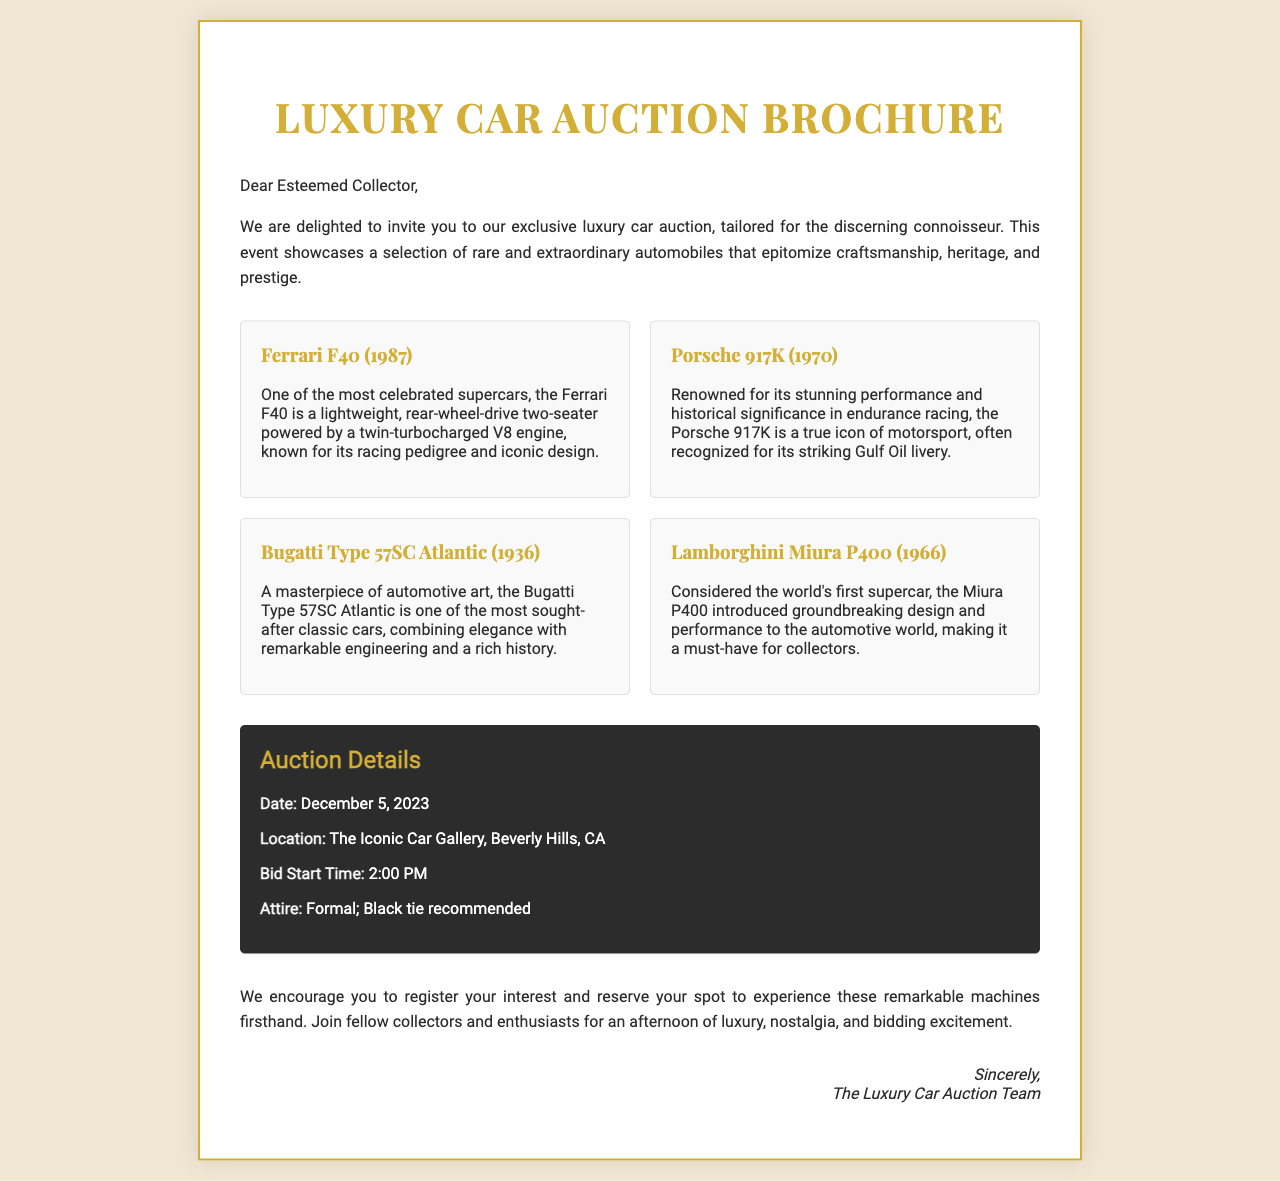What is the date of the auction? The date of the auction is explicitly stated in the document under the auction details section.
Answer: December 5, 2023 Where is the auction taking place? The location of the auction is provided in the auction details section.
Answer: The Iconic Car Gallery, Beverly Hills, CA What is the name of the first car listed in the brochure? The first car listed in the models section is mentioned by name.
Answer: Ferrari F40 What time does the bidding start? The bidding start time is clearly indicated in the auction details section.
Answer: 2:00 PM Which model is described as the world's first supercar? The document mentions this specific detail in the description of one of the models.
Answer: Lamborghini Miura P400 What type of attire is recommended for the auction? The recommended attire is explicitly mentioned in the auction details section.
Answer: Formal; Black tie recommended What car is known for its Gulf Oil livery? The document refers to this specific car in its description within the models section.
Answer: Porsche 917K Which car model is described as a masterpiece of automotive art? This description is provided in the details of one of the models listed.
Answer: Bugatti Type 57SC Atlantic Who is the letter addressed to? The document starts by addressing a specific audience, which is mentioned in the introduction.
Answer: Esteemed Collector 